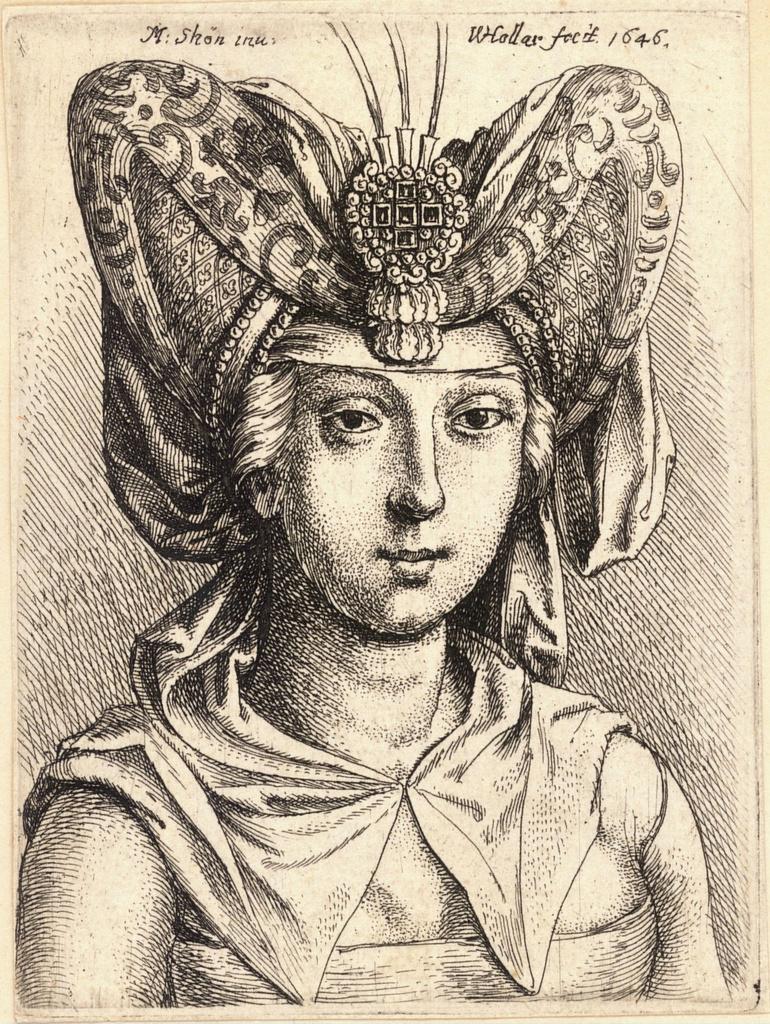In one or two sentences, can you explain what this image depicts? This picture is an art of a person, at the top there is some text and numbers on this poster. 